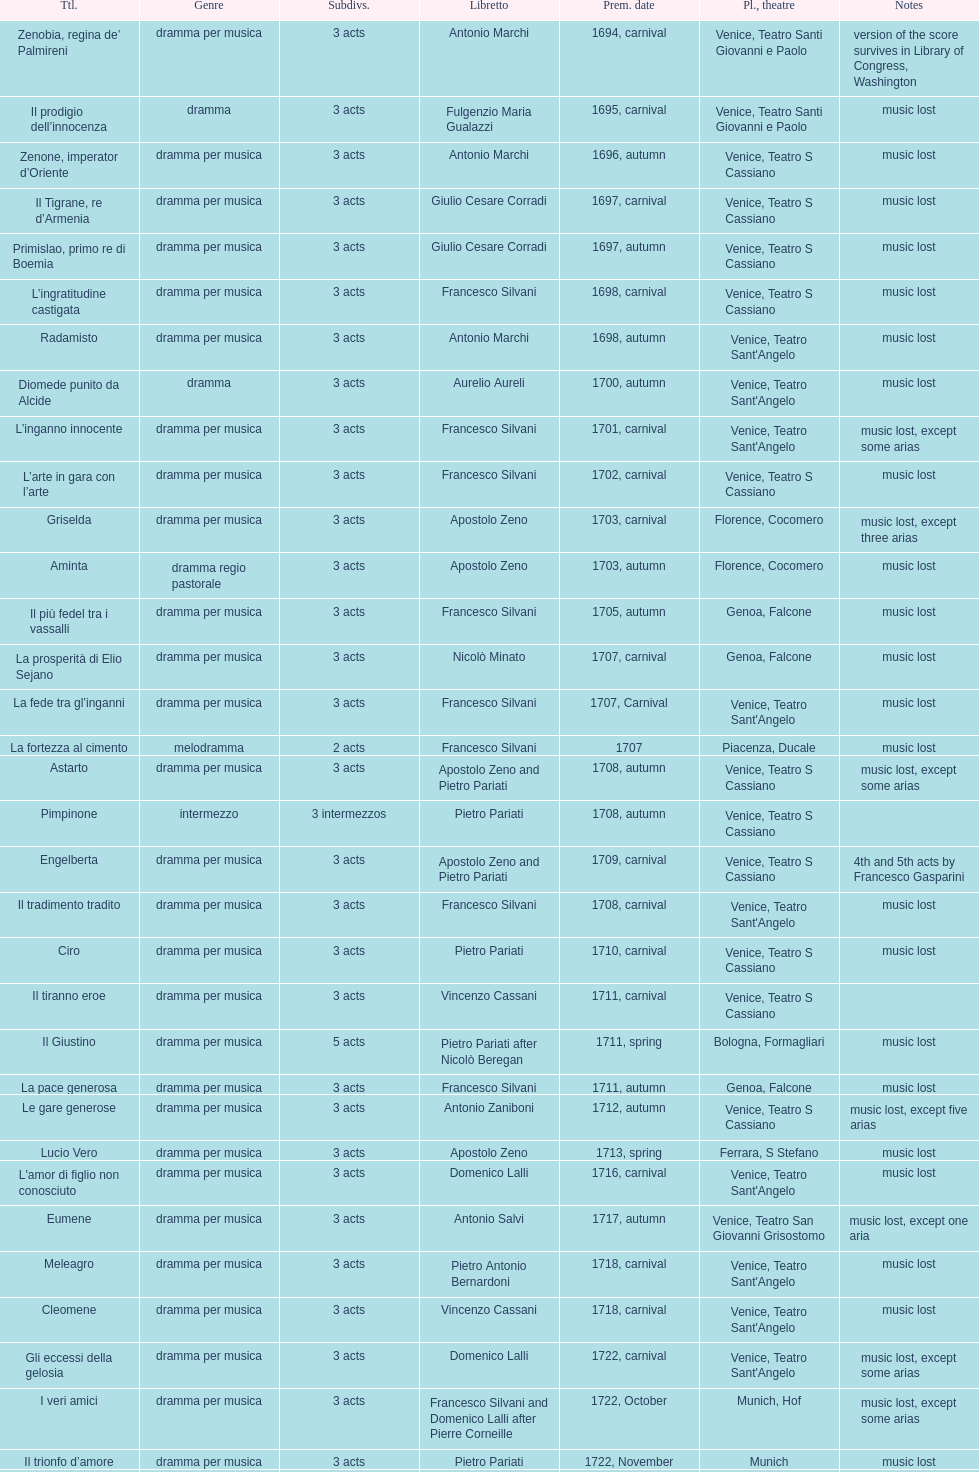What quantity of acts does il giustino consist of? 5. 